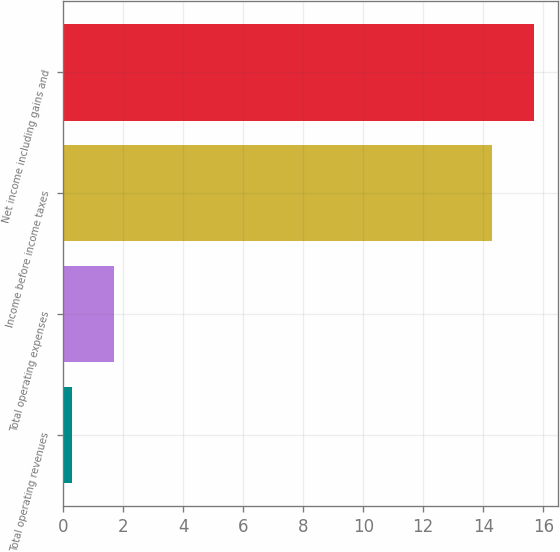Convert chart to OTSL. <chart><loc_0><loc_0><loc_500><loc_500><bar_chart><fcel>Total operating revenues<fcel>Total operating expenses<fcel>Income before income taxes<fcel>Net income including gains and<nl><fcel>0.3<fcel>1.7<fcel>14.3<fcel>15.7<nl></chart> 